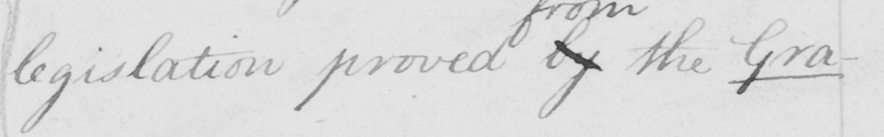Please transcribe the handwritten text in this image. legislation proved by the Gra- 